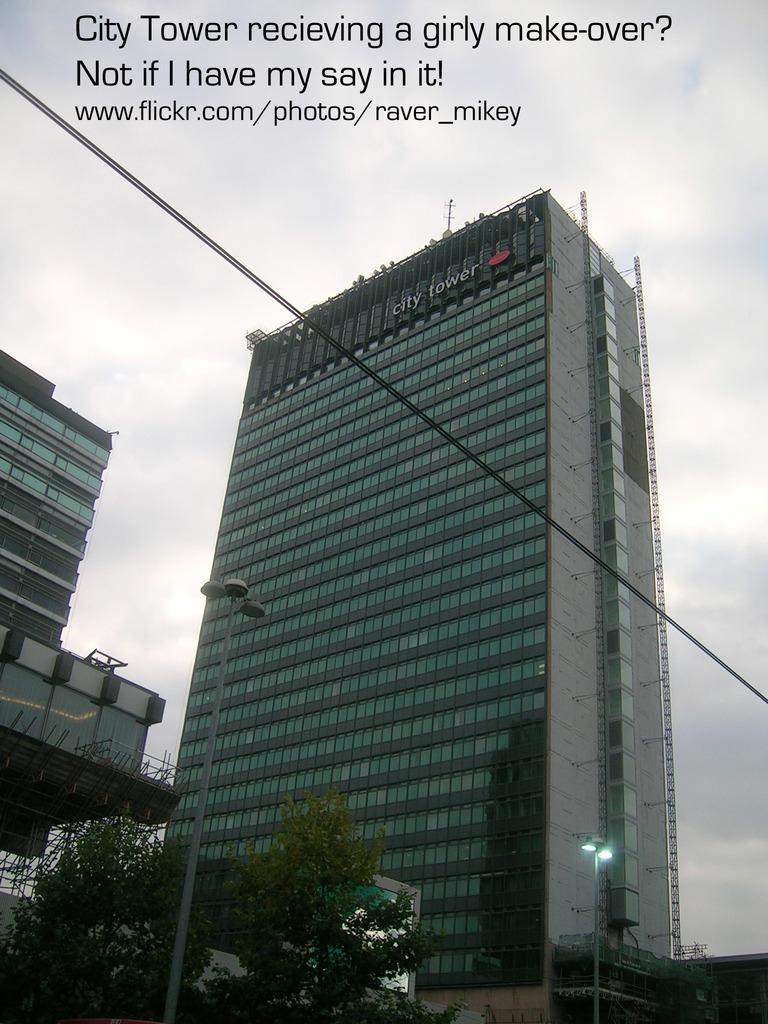In one or two sentences, can you explain what this image depicts? In this image I can see the buildings. On the building I can see the name city tower is written. In the front of the building there are trees. In the background I can see the clouds and the sky and there is a the text written in the top. 